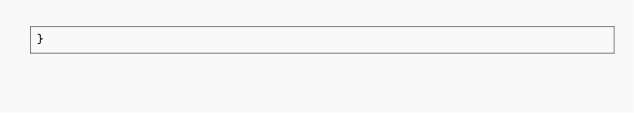Convert code to text. <code><loc_0><loc_0><loc_500><loc_500><_CSS_>}
</code> 